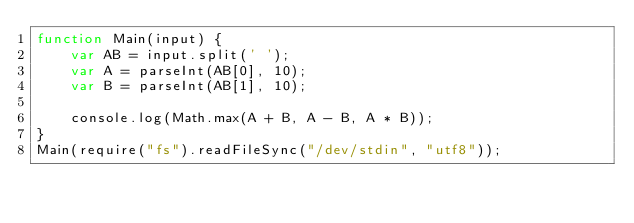<code> <loc_0><loc_0><loc_500><loc_500><_JavaScript_>function Main(input) {
    var AB = input.split(' ');
    var A = parseInt(AB[0], 10);
    var B = parseInt(AB[1], 10);
    
    console.log(Math.max(A + B, A - B, A * B));
}
Main(require("fs").readFileSync("/dev/stdin", "utf8"));</code> 